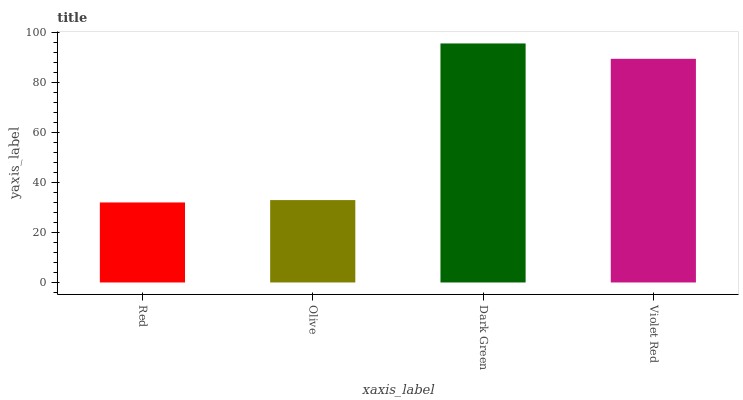Is Red the minimum?
Answer yes or no. Yes. Is Dark Green the maximum?
Answer yes or no. Yes. Is Olive the minimum?
Answer yes or no. No. Is Olive the maximum?
Answer yes or no. No. Is Olive greater than Red?
Answer yes or no. Yes. Is Red less than Olive?
Answer yes or no. Yes. Is Red greater than Olive?
Answer yes or no. No. Is Olive less than Red?
Answer yes or no. No. Is Violet Red the high median?
Answer yes or no. Yes. Is Olive the low median?
Answer yes or no. Yes. Is Dark Green the high median?
Answer yes or no. No. Is Red the low median?
Answer yes or no. No. 